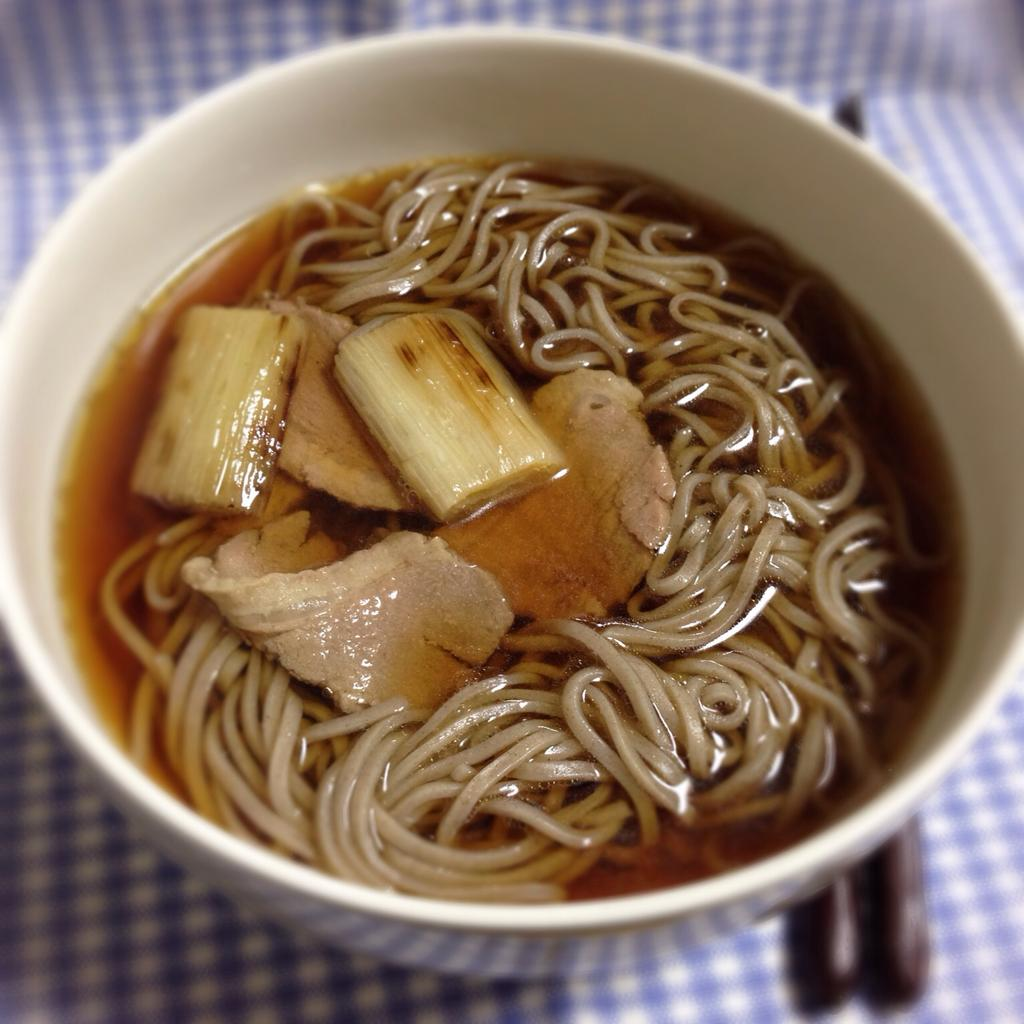What is the main subject of the image? There is a food item in the image. How is the food item presented in the image? The food item is in a bowl. How many geese are wearing masks in the image? There are no geese or masks present in the image. 